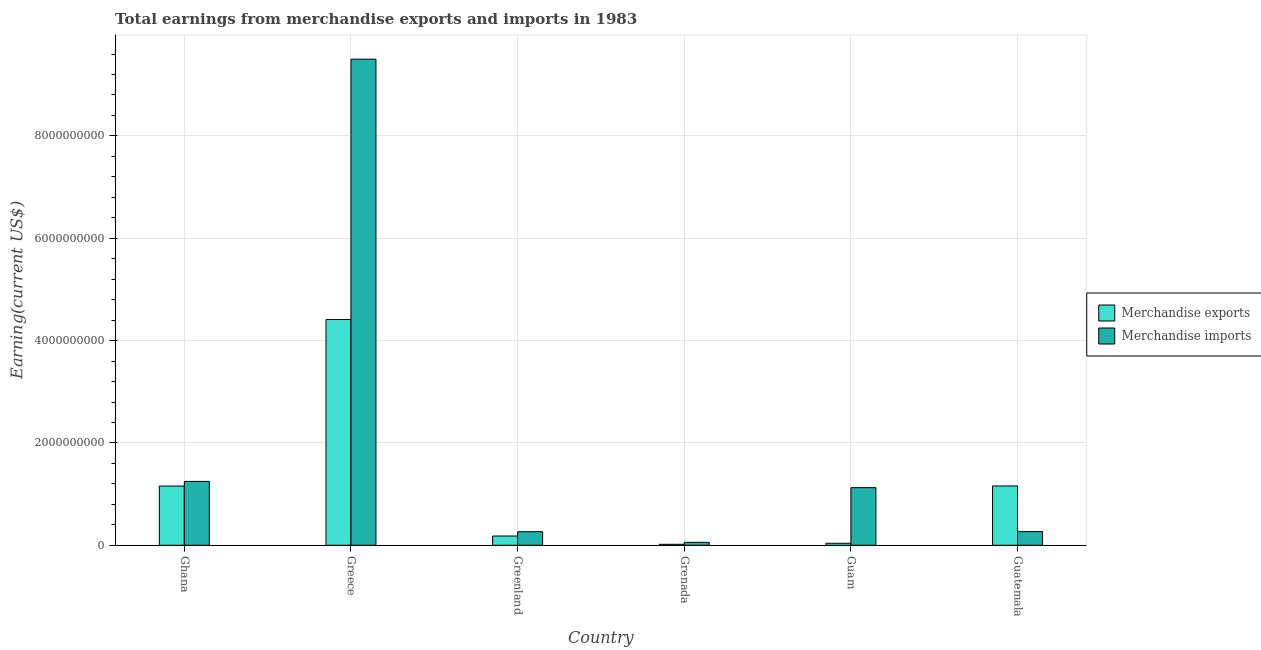How many different coloured bars are there?
Offer a very short reply. 2. How many groups of bars are there?
Offer a very short reply. 6. Are the number of bars on each tick of the X-axis equal?
Give a very brief answer. Yes. How many bars are there on the 5th tick from the right?
Offer a very short reply. 2. In how many cases, is the number of bars for a given country not equal to the number of legend labels?
Your answer should be very brief. 0. What is the earnings from merchandise imports in Guam?
Offer a terse response. 1.13e+09. Across all countries, what is the maximum earnings from merchandise imports?
Provide a short and direct response. 9.50e+09. Across all countries, what is the minimum earnings from merchandise exports?
Provide a short and direct response. 1.90e+07. In which country was the earnings from merchandise imports maximum?
Make the answer very short. Greece. In which country was the earnings from merchandise imports minimum?
Provide a succinct answer. Grenada. What is the total earnings from merchandise exports in the graph?
Provide a short and direct response. 6.97e+09. What is the difference between the earnings from merchandise exports in Greenland and the earnings from merchandise imports in Guam?
Provide a short and direct response. -9.45e+08. What is the average earnings from merchandise imports per country?
Offer a terse response. 2.08e+09. What is the difference between the earnings from merchandise imports and earnings from merchandise exports in Greenland?
Your answer should be compact. 8.40e+07. In how many countries, is the earnings from merchandise exports greater than 2000000000 US$?
Your answer should be compact. 1. What is the ratio of the earnings from merchandise imports in Greenland to that in Grenada?
Your response must be concise. 4.65. Is the earnings from merchandise exports in Ghana less than that in Guam?
Ensure brevity in your answer.  No. Is the difference between the earnings from merchandise imports in Ghana and Greenland greater than the difference between the earnings from merchandise exports in Ghana and Greenland?
Make the answer very short. Yes. What is the difference between the highest and the second highest earnings from merchandise imports?
Offer a very short reply. 8.25e+09. What is the difference between the highest and the lowest earnings from merchandise exports?
Provide a short and direct response. 4.39e+09. In how many countries, is the earnings from merchandise exports greater than the average earnings from merchandise exports taken over all countries?
Give a very brief answer. 1. Are all the bars in the graph horizontal?
Your response must be concise. No. Are the values on the major ticks of Y-axis written in scientific E-notation?
Keep it short and to the point. No. Does the graph contain grids?
Provide a succinct answer. Yes. How are the legend labels stacked?
Give a very brief answer. Vertical. What is the title of the graph?
Your response must be concise. Total earnings from merchandise exports and imports in 1983. What is the label or title of the X-axis?
Your answer should be compact. Country. What is the label or title of the Y-axis?
Your answer should be very brief. Earning(current US$). What is the Earning(current US$) in Merchandise exports in Ghana?
Provide a short and direct response. 1.16e+09. What is the Earning(current US$) in Merchandise imports in Ghana?
Keep it short and to the point. 1.25e+09. What is the Earning(current US$) in Merchandise exports in Greece?
Give a very brief answer. 4.41e+09. What is the Earning(current US$) in Merchandise imports in Greece?
Make the answer very short. 9.50e+09. What is the Earning(current US$) of Merchandise exports in Greenland?
Give a very brief answer. 1.81e+08. What is the Earning(current US$) in Merchandise imports in Greenland?
Offer a very short reply. 2.65e+08. What is the Earning(current US$) in Merchandise exports in Grenada?
Offer a very short reply. 1.90e+07. What is the Earning(current US$) of Merchandise imports in Grenada?
Ensure brevity in your answer.  5.70e+07. What is the Earning(current US$) in Merchandise exports in Guam?
Keep it short and to the point. 3.90e+07. What is the Earning(current US$) of Merchandise imports in Guam?
Offer a terse response. 1.13e+09. What is the Earning(current US$) in Merchandise exports in Guatemala?
Offer a very short reply. 1.16e+09. What is the Earning(current US$) in Merchandise imports in Guatemala?
Make the answer very short. 2.67e+08. Across all countries, what is the maximum Earning(current US$) of Merchandise exports?
Offer a very short reply. 4.41e+09. Across all countries, what is the maximum Earning(current US$) of Merchandise imports?
Offer a very short reply. 9.50e+09. Across all countries, what is the minimum Earning(current US$) of Merchandise exports?
Provide a succinct answer. 1.90e+07. Across all countries, what is the minimum Earning(current US$) in Merchandise imports?
Offer a terse response. 5.70e+07. What is the total Earning(current US$) in Merchandise exports in the graph?
Give a very brief answer. 6.97e+09. What is the total Earning(current US$) of Merchandise imports in the graph?
Provide a succinct answer. 1.25e+1. What is the difference between the Earning(current US$) in Merchandise exports in Ghana and that in Greece?
Offer a very short reply. -3.26e+09. What is the difference between the Earning(current US$) of Merchandise imports in Ghana and that in Greece?
Ensure brevity in your answer.  -8.25e+09. What is the difference between the Earning(current US$) in Merchandise exports in Ghana and that in Greenland?
Your answer should be compact. 9.77e+08. What is the difference between the Earning(current US$) in Merchandise imports in Ghana and that in Greenland?
Keep it short and to the point. 9.83e+08. What is the difference between the Earning(current US$) in Merchandise exports in Ghana and that in Grenada?
Your response must be concise. 1.14e+09. What is the difference between the Earning(current US$) in Merchandise imports in Ghana and that in Grenada?
Give a very brief answer. 1.19e+09. What is the difference between the Earning(current US$) of Merchandise exports in Ghana and that in Guam?
Ensure brevity in your answer.  1.12e+09. What is the difference between the Earning(current US$) in Merchandise imports in Ghana and that in Guam?
Make the answer very short. 1.22e+08. What is the difference between the Earning(current US$) of Merchandise exports in Ghana and that in Guatemala?
Your response must be concise. -1.00e+06. What is the difference between the Earning(current US$) of Merchandise imports in Ghana and that in Guatemala?
Give a very brief answer. 9.81e+08. What is the difference between the Earning(current US$) of Merchandise exports in Greece and that in Greenland?
Ensure brevity in your answer.  4.23e+09. What is the difference between the Earning(current US$) in Merchandise imports in Greece and that in Greenland?
Provide a succinct answer. 9.24e+09. What is the difference between the Earning(current US$) in Merchandise exports in Greece and that in Grenada?
Provide a succinct answer. 4.39e+09. What is the difference between the Earning(current US$) of Merchandise imports in Greece and that in Grenada?
Provide a short and direct response. 9.44e+09. What is the difference between the Earning(current US$) in Merchandise exports in Greece and that in Guam?
Give a very brief answer. 4.37e+09. What is the difference between the Earning(current US$) of Merchandise imports in Greece and that in Guam?
Your response must be concise. 8.37e+09. What is the difference between the Earning(current US$) of Merchandise exports in Greece and that in Guatemala?
Offer a very short reply. 3.25e+09. What is the difference between the Earning(current US$) in Merchandise imports in Greece and that in Guatemala?
Make the answer very short. 9.23e+09. What is the difference between the Earning(current US$) of Merchandise exports in Greenland and that in Grenada?
Give a very brief answer. 1.62e+08. What is the difference between the Earning(current US$) in Merchandise imports in Greenland and that in Grenada?
Offer a very short reply. 2.08e+08. What is the difference between the Earning(current US$) in Merchandise exports in Greenland and that in Guam?
Provide a short and direct response. 1.42e+08. What is the difference between the Earning(current US$) of Merchandise imports in Greenland and that in Guam?
Your answer should be very brief. -8.61e+08. What is the difference between the Earning(current US$) in Merchandise exports in Greenland and that in Guatemala?
Give a very brief answer. -9.78e+08. What is the difference between the Earning(current US$) of Merchandise imports in Greenland and that in Guatemala?
Keep it short and to the point. -2.00e+06. What is the difference between the Earning(current US$) in Merchandise exports in Grenada and that in Guam?
Ensure brevity in your answer.  -2.00e+07. What is the difference between the Earning(current US$) of Merchandise imports in Grenada and that in Guam?
Provide a succinct answer. -1.07e+09. What is the difference between the Earning(current US$) in Merchandise exports in Grenada and that in Guatemala?
Give a very brief answer. -1.14e+09. What is the difference between the Earning(current US$) of Merchandise imports in Grenada and that in Guatemala?
Make the answer very short. -2.10e+08. What is the difference between the Earning(current US$) of Merchandise exports in Guam and that in Guatemala?
Give a very brief answer. -1.12e+09. What is the difference between the Earning(current US$) of Merchandise imports in Guam and that in Guatemala?
Offer a very short reply. 8.59e+08. What is the difference between the Earning(current US$) of Merchandise exports in Ghana and the Earning(current US$) of Merchandise imports in Greece?
Offer a terse response. -8.34e+09. What is the difference between the Earning(current US$) in Merchandise exports in Ghana and the Earning(current US$) in Merchandise imports in Greenland?
Give a very brief answer. 8.93e+08. What is the difference between the Earning(current US$) of Merchandise exports in Ghana and the Earning(current US$) of Merchandise imports in Grenada?
Your response must be concise. 1.10e+09. What is the difference between the Earning(current US$) in Merchandise exports in Ghana and the Earning(current US$) in Merchandise imports in Guam?
Your answer should be compact. 3.20e+07. What is the difference between the Earning(current US$) of Merchandise exports in Ghana and the Earning(current US$) of Merchandise imports in Guatemala?
Offer a very short reply. 8.91e+08. What is the difference between the Earning(current US$) in Merchandise exports in Greece and the Earning(current US$) in Merchandise imports in Greenland?
Ensure brevity in your answer.  4.15e+09. What is the difference between the Earning(current US$) of Merchandise exports in Greece and the Earning(current US$) of Merchandise imports in Grenada?
Your answer should be compact. 4.36e+09. What is the difference between the Earning(current US$) of Merchandise exports in Greece and the Earning(current US$) of Merchandise imports in Guam?
Make the answer very short. 3.29e+09. What is the difference between the Earning(current US$) in Merchandise exports in Greece and the Earning(current US$) in Merchandise imports in Guatemala?
Offer a very short reply. 4.15e+09. What is the difference between the Earning(current US$) in Merchandise exports in Greenland and the Earning(current US$) in Merchandise imports in Grenada?
Provide a succinct answer. 1.24e+08. What is the difference between the Earning(current US$) in Merchandise exports in Greenland and the Earning(current US$) in Merchandise imports in Guam?
Your answer should be very brief. -9.45e+08. What is the difference between the Earning(current US$) in Merchandise exports in Greenland and the Earning(current US$) in Merchandise imports in Guatemala?
Provide a succinct answer. -8.60e+07. What is the difference between the Earning(current US$) of Merchandise exports in Grenada and the Earning(current US$) of Merchandise imports in Guam?
Provide a succinct answer. -1.11e+09. What is the difference between the Earning(current US$) in Merchandise exports in Grenada and the Earning(current US$) in Merchandise imports in Guatemala?
Ensure brevity in your answer.  -2.48e+08. What is the difference between the Earning(current US$) in Merchandise exports in Guam and the Earning(current US$) in Merchandise imports in Guatemala?
Provide a succinct answer. -2.28e+08. What is the average Earning(current US$) in Merchandise exports per country?
Your answer should be very brief. 1.16e+09. What is the average Earning(current US$) of Merchandise imports per country?
Your answer should be compact. 2.08e+09. What is the difference between the Earning(current US$) of Merchandise exports and Earning(current US$) of Merchandise imports in Ghana?
Make the answer very short. -9.00e+07. What is the difference between the Earning(current US$) in Merchandise exports and Earning(current US$) in Merchandise imports in Greece?
Keep it short and to the point. -5.09e+09. What is the difference between the Earning(current US$) in Merchandise exports and Earning(current US$) in Merchandise imports in Greenland?
Offer a terse response. -8.40e+07. What is the difference between the Earning(current US$) in Merchandise exports and Earning(current US$) in Merchandise imports in Grenada?
Your response must be concise. -3.80e+07. What is the difference between the Earning(current US$) of Merchandise exports and Earning(current US$) of Merchandise imports in Guam?
Make the answer very short. -1.09e+09. What is the difference between the Earning(current US$) in Merchandise exports and Earning(current US$) in Merchandise imports in Guatemala?
Offer a very short reply. 8.92e+08. What is the ratio of the Earning(current US$) in Merchandise exports in Ghana to that in Greece?
Provide a succinct answer. 0.26. What is the ratio of the Earning(current US$) in Merchandise imports in Ghana to that in Greece?
Make the answer very short. 0.13. What is the ratio of the Earning(current US$) in Merchandise exports in Ghana to that in Greenland?
Your answer should be compact. 6.4. What is the ratio of the Earning(current US$) in Merchandise imports in Ghana to that in Greenland?
Keep it short and to the point. 4.71. What is the ratio of the Earning(current US$) of Merchandise exports in Ghana to that in Grenada?
Your answer should be compact. 60.95. What is the ratio of the Earning(current US$) of Merchandise imports in Ghana to that in Grenada?
Offer a very short reply. 21.89. What is the ratio of the Earning(current US$) of Merchandise exports in Ghana to that in Guam?
Your answer should be very brief. 29.69. What is the ratio of the Earning(current US$) of Merchandise imports in Ghana to that in Guam?
Provide a succinct answer. 1.11. What is the ratio of the Earning(current US$) in Merchandise exports in Ghana to that in Guatemala?
Provide a short and direct response. 1. What is the ratio of the Earning(current US$) of Merchandise imports in Ghana to that in Guatemala?
Your answer should be compact. 4.67. What is the ratio of the Earning(current US$) of Merchandise exports in Greece to that in Greenland?
Provide a succinct answer. 24.38. What is the ratio of the Earning(current US$) of Merchandise imports in Greece to that in Greenland?
Provide a short and direct response. 35.85. What is the ratio of the Earning(current US$) of Merchandise exports in Greece to that in Grenada?
Ensure brevity in your answer.  232.26. What is the ratio of the Earning(current US$) of Merchandise imports in Greece to that in Grenada?
Your answer should be very brief. 166.67. What is the ratio of the Earning(current US$) in Merchandise exports in Greece to that in Guam?
Your answer should be compact. 113.15. What is the ratio of the Earning(current US$) in Merchandise imports in Greece to that in Guam?
Provide a succinct answer. 8.44. What is the ratio of the Earning(current US$) of Merchandise exports in Greece to that in Guatemala?
Provide a succinct answer. 3.81. What is the ratio of the Earning(current US$) in Merchandise imports in Greece to that in Guatemala?
Offer a terse response. 35.58. What is the ratio of the Earning(current US$) of Merchandise exports in Greenland to that in Grenada?
Offer a very short reply. 9.53. What is the ratio of the Earning(current US$) of Merchandise imports in Greenland to that in Grenada?
Keep it short and to the point. 4.65. What is the ratio of the Earning(current US$) of Merchandise exports in Greenland to that in Guam?
Ensure brevity in your answer.  4.64. What is the ratio of the Earning(current US$) of Merchandise imports in Greenland to that in Guam?
Offer a very short reply. 0.24. What is the ratio of the Earning(current US$) in Merchandise exports in Greenland to that in Guatemala?
Offer a very short reply. 0.16. What is the ratio of the Earning(current US$) in Merchandise exports in Grenada to that in Guam?
Make the answer very short. 0.49. What is the ratio of the Earning(current US$) in Merchandise imports in Grenada to that in Guam?
Your answer should be very brief. 0.05. What is the ratio of the Earning(current US$) in Merchandise exports in Grenada to that in Guatemala?
Ensure brevity in your answer.  0.02. What is the ratio of the Earning(current US$) in Merchandise imports in Grenada to that in Guatemala?
Keep it short and to the point. 0.21. What is the ratio of the Earning(current US$) of Merchandise exports in Guam to that in Guatemala?
Provide a succinct answer. 0.03. What is the ratio of the Earning(current US$) in Merchandise imports in Guam to that in Guatemala?
Make the answer very short. 4.22. What is the difference between the highest and the second highest Earning(current US$) in Merchandise exports?
Give a very brief answer. 3.25e+09. What is the difference between the highest and the second highest Earning(current US$) of Merchandise imports?
Ensure brevity in your answer.  8.25e+09. What is the difference between the highest and the lowest Earning(current US$) of Merchandise exports?
Your response must be concise. 4.39e+09. What is the difference between the highest and the lowest Earning(current US$) of Merchandise imports?
Provide a short and direct response. 9.44e+09. 